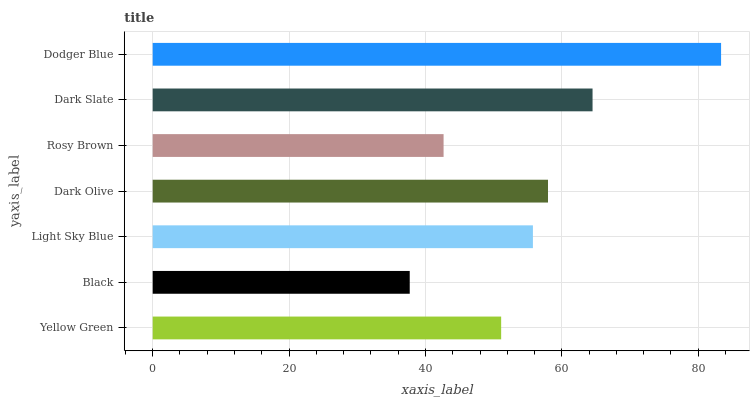Is Black the minimum?
Answer yes or no. Yes. Is Dodger Blue the maximum?
Answer yes or no. Yes. Is Light Sky Blue the minimum?
Answer yes or no. No. Is Light Sky Blue the maximum?
Answer yes or no. No. Is Light Sky Blue greater than Black?
Answer yes or no. Yes. Is Black less than Light Sky Blue?
Answer yes or no. Yes. Is Black greater than Light Sky Blue?
Answer yes or no. No. Is Light Sky Blue less than Black?
Answer yes or no. No. Is Light Sky Blue the high median?
Answer yes or no. Yes. Is Light Sky Blue the low median?
Answer yes or no. Yes. Is Dodger Blue the high median?
Answer yes or no. No. Is Dodger Blue the low median?
Answer yes or no. No. 